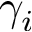<formula> <loc_0><loc_0><loc_500><loc_500>\gamma _ { i }</formula> 